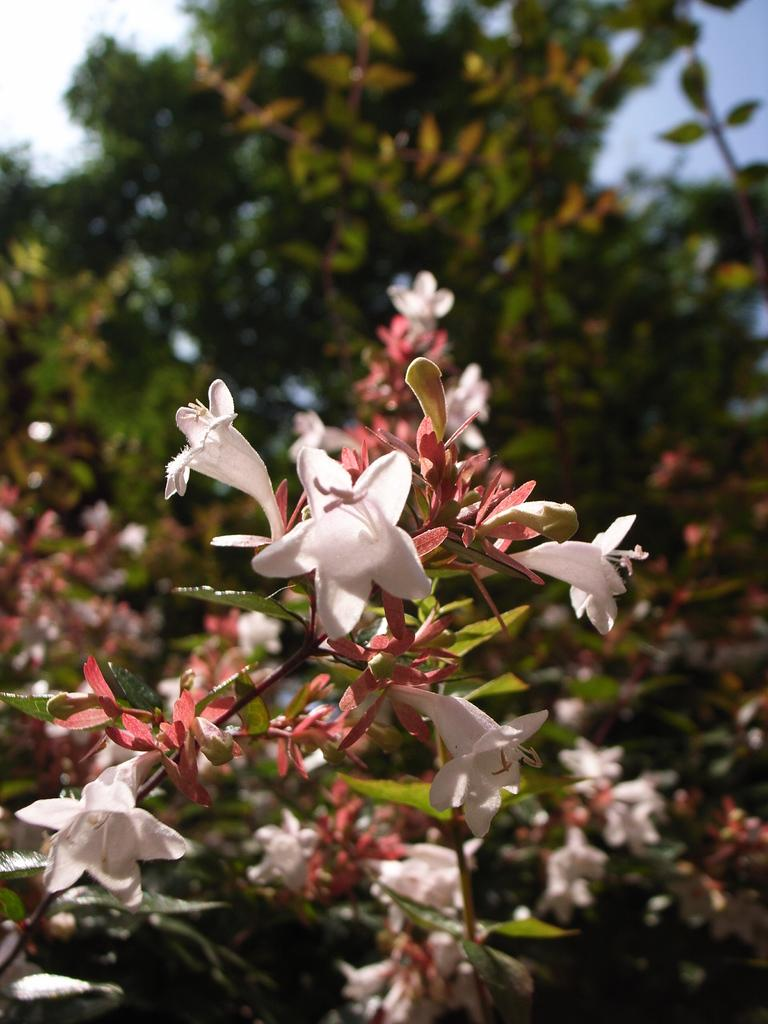What is the main subject in the center of the image? There is a plant in the center of the image. What color are the flowers on the plant? The plant has white flowers. What can be seen in the background of the image? There are trees and the sky visible in the background of the image. What type of wool is being used to create the plant's expansion in the image? There is no wool or expansion mentioned in the image; it features a plant with white flowers and a background of trees and the sky. 